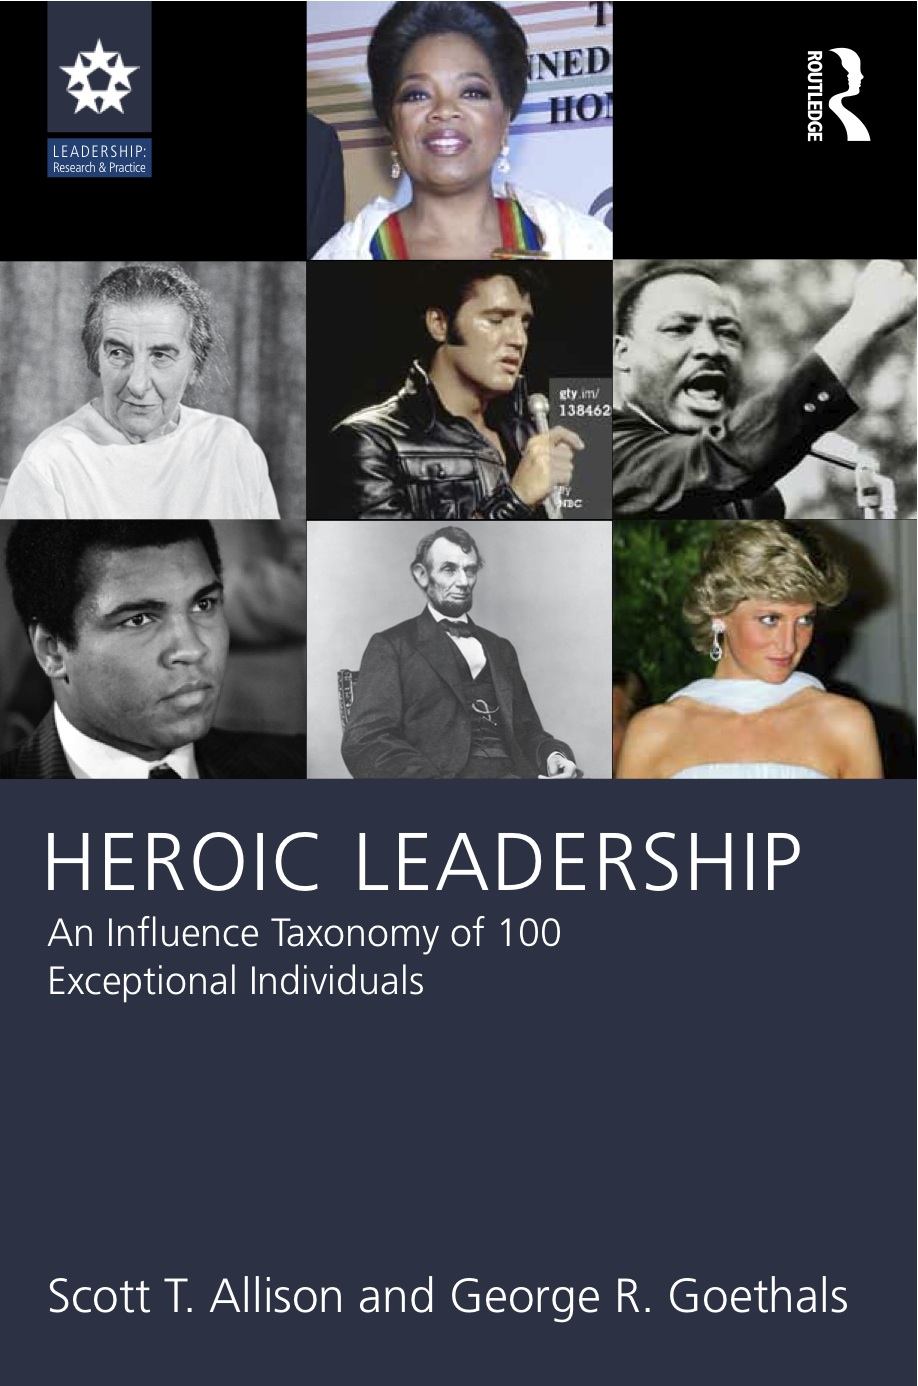What significant achievements or actions might have led to the inclusion of the female leader at the top of the book cover? The female leader at the top of the cover is included likely due to her transformative contributions to media and philanthropy. She broke barriers in the broadcasting industry, becoming a prominent talk show host and influencing public opinion on numerous social issues. Her extensive charitable work and advocacy for education and children's rights further establish her as a model of 'Heroic Leadership.' 